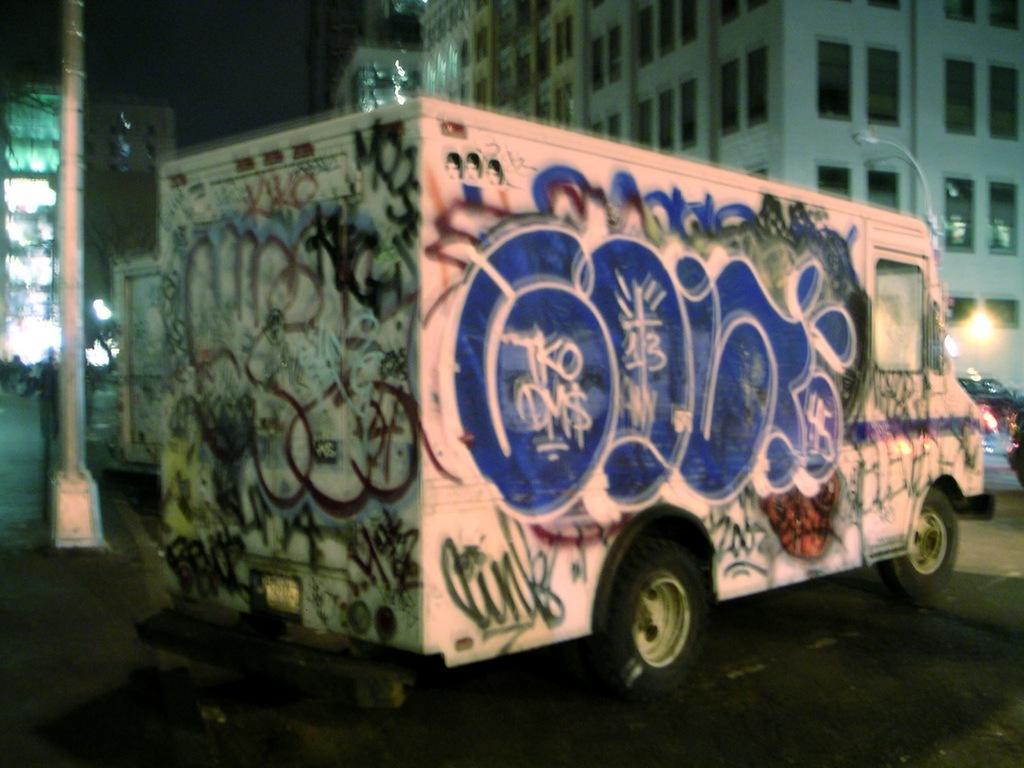Describe this image in one or two sentences. In this image, we can see a truck on the road. Background we can see few buildings, poles, lights, walls, windows, vehicles, tree and sky. 